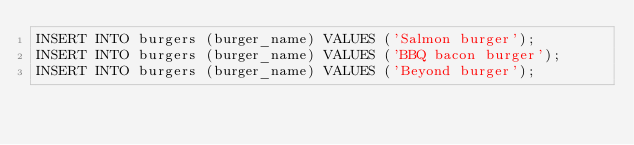Convert code to text. <code><loc_0><loc_0><loc_500><loc_500><_SQL_>INSERT INTO burgers (burger_name) VALUES ('Salmon burger');
INSERT INTO burgers (burger_name) VALUES ('BBQ bacon burger');
INSERT INTO burgers (burger_name) VALUES ('Beyond burger');</code> 